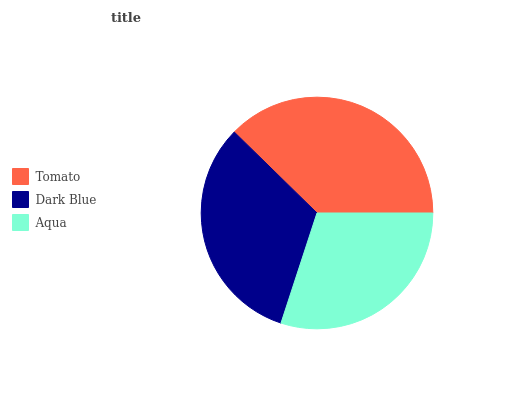Is Aqua the minimum?
Answer yes or no. Yes. Is Tomato the maximum?
Answer yes or no. Yes. Is Dark Blue the minimum?
Answer yes or no. No. Is Dark Blue the maximum?
Answer yes or no. No. Is Tomato greater than Dark Blue?
Answer yes or no. Yes. Is Dark Blue less than Tomato?
Answer yes or no. Yes. Is Dark Blue greater than Tomato?
Answer yes or no. No. Is Tomato less than Dark Blue?
Answer yes or no. No. Is Dark Blue the high median?
Answer yes or no. Yes. Is Dark Blue the low median?
Answer yes or no. Yes. Is Aqua the high median?
Answer yes or no. No. Is Tomato the low median?
Answer yes or no. No. 